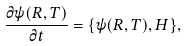<formula> <loc_0><loc_0><loc_500><loc_500>\frac { \partial \psi ( R , T ) } { \partial t } = \{ \psi ( R , T ) , H \} ,</formula> 